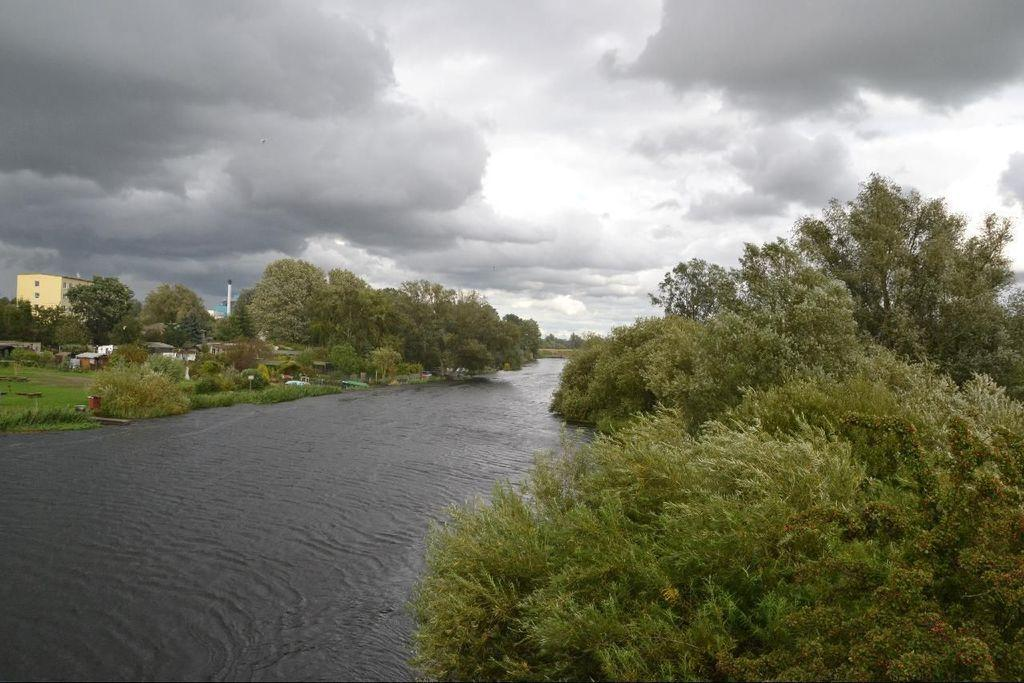What type of vegetation can be seen in the image? There are trees in the image. What natural element is visible in the image? There is water visible in the image. What structures are located on the left side of the image? There are houses, a pole, and a building on the left side of the image. What is the condition of the sky in the image? The sky is cloudy and visible at the top of the image. Where is the mom's stomach located in the image? There is no mom or stomach present in the image. What type of scissors can be seen cutting the grass in the image? There are no scissors or grass cutting activity depicted in the image. 